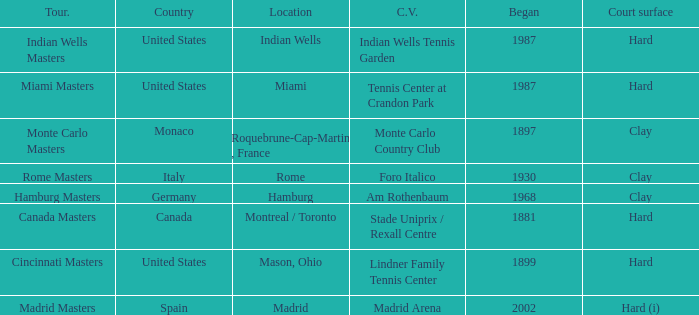In which country is rome located? Italy. 